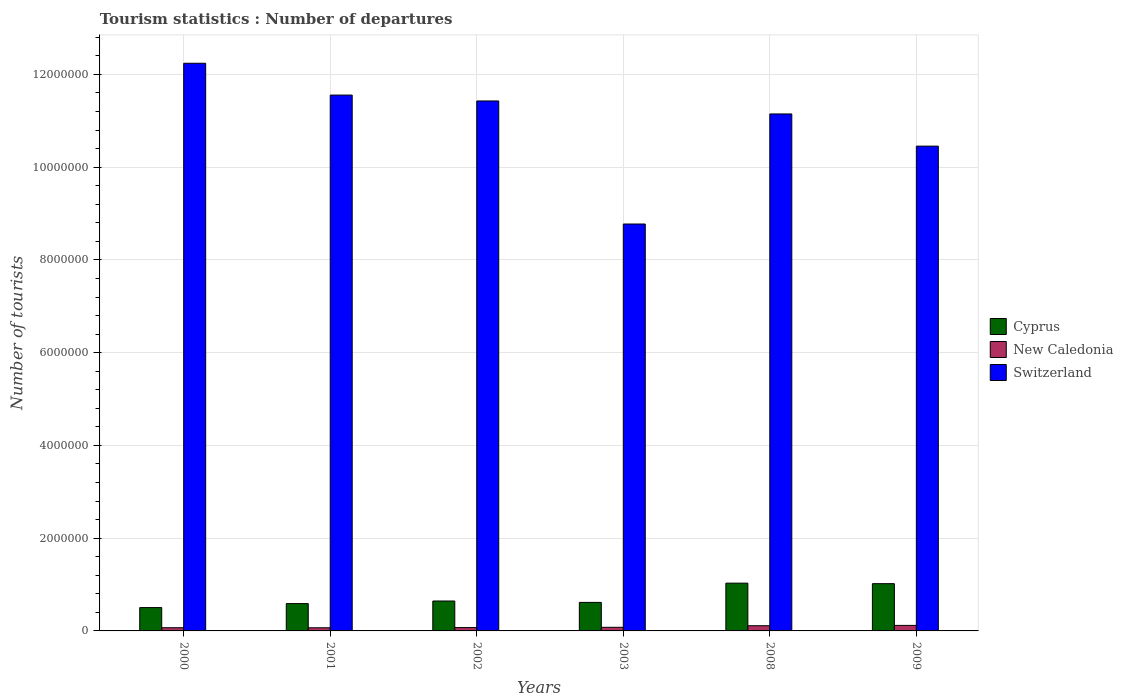How many different coloured bars are there?
Your response must be concise. 3. Are the number of bars per tick equal to the number of legend labels?
Your answer should be compact. Yes. How many bars are there on the 6th tick from the right?
Give a very brief answer. 3. In how many cases, is the number of bars for a given year not equal to the number of legend labels?
Ensure brevity in your answer.  0. What is the number of tourist departures in Cyprus in 2003?
Give a very brief answer. 6.15e+05. Across all years, what is the maximum number of tourist departures in Switzerland?
Your answer should be very brief. 1.22e+07. Across all years, what is the minimum number of tourist departures in New Caledonia?
Offer a terse response. 6.80e+04. In which year was the number of tourist departures in New Caledonia minimum?
Your answer should be very brief. 2001. What is the total number of tourist departures in Switzerland in the graph?
Ensure brevity in your answer.  6.56e+07. What is the difference between the number of tourist departures in Cyprus in 2002 and that in 2009?
Your response must be concise. -3.74e+05. What is the difference between the number of tourist departures in New Caledonia in 2001 and the number of tourist departures in Switzerland in 2002?
Give a very brief answer. -1.14e+07. What is the average number of tourist departures in New Caledonia per year?
Keep it short and to the point. 8.63e+04. In the year 2001, what is the difference between the number of tourist departures in New Caledonia and number of tourist departures in Cyprus?
Offer a very short reply. -5.21e+05. In how many years, is the number of tourist departures in Cyprus greater than 2400000?
Offer a very short reply. 0. What is the ratio of the number of tourist departures in Cyprus in 2001 to that in 2008?
Keep it short and to the point. 0.57. Is the number of tourist departures in Cyprus in 2000 less than that in 2009?
Provide a succinct answer. Yes. Is the difference between the number of tourist departures in New Caledonia in 2000 and 2009 greater than the difference between the number of tourist departures in Cyprus in 2000 and 2009?
Provide a short and direct response. Yes. What is the difference between the highest and the second highest number of tourist departures in New Caledonia?
Provide a succinct answer. 7000. What is the difference between the highest and the lowest number of tourist departures in Cyprus?
Your response must be concise. 5.27e+05. Is the sum of the number of tourist departures in Cyprus in 2000 and 2008 greater than the maximum number of tourist departures in New Caledonia across all years?
Offer a terse response. Yes. What does the 1st bar from the left in 2002 represents?
Your answer should be compact. Cyprus. What does the 2nd bar from the right in 2009 represents?
Offer a terse response. New Caledonia. Is it the case that in every year, the sum of the number of tourist departures in Switzerland and number of tourist departures in New Caledonia is greater than the number of tourist departures in Cyprus?
Your answer should be compact. Yes. How many bars are there?
Your response must be concise. 18. Are all the bars in the graph horizontal?
Your answer should be very brief. No. Are the values on the major ticks of Y-axis written in scientific E-notation?
Offer a terse response. No. Does the graph contain any zero values?
Offer a terse response. No. Does the graph contain grids?
Your answer should be compact. Yes. Where does the legend appear in the graph?
Your answer should be compact. Center right. What is the title of the graph?
Your answer should be compact. Tourism statistics : Number of departures. Does "Tunisia" appear as one of the legend labels in the graph?
Provide a short and direct response. No. What is the label or title of the Y-axis?
Your answer should be compact. Number of tourists. What is the Number of tourists of Cyprus in 2000?
Give a very brief answer. 5.03e+05. What is the Number of tourists in New Caledonia in 2000?
Give a very brief answer. 6.90e+04. What is the Number of tourists of Switzerland in 2000?
Your answer should be compact. 1.22e+07. What is the Number of tourists of Cyprus in 2001?
Your answer should be very brief. 5.89e+05. What is the Number of tourists of New Caledonia in 2001?
Offer a terse response. 6.80e+04. What is the Number of tourists in Switzerland in 2001?
Your answer should be very brief. 1.16e+07. What is the Number of tourists of Cyprus in 2002?
Make the answer very short. 6.45e+05. What is the Number of tourists of New Caledonia in 2002?
Keep it short and to the point. 7.20e+04. What is the Number of tourists of Switzerland in 2002?
Offer a very short reply. 1.14e+07. What is the Number of tourists in Cyprus in 2003?
Your answer should be very brief. 6.15e+05. What is the Number of tourists in New Caledonia in 2003?
Your answer should be compact. 7.80e+04. What is the Number of tourists in Switzerland in 2003?
Keep it short and to the point. 8.77e+06. What is the Number of tourists in Cyprus in 2008?
Your answer should be very brief. 1.03e+06. What is the Number of tourists of New Caledonia in 2008?
Offer a terse response. 1.12e+05. What is the Number of tourists in Switzerland in 2008?
Offer a terse response. 1.11e+07. What is the Number of tourists in Cyprus in 2009?
Your answer should be very brief. 1.02e+06. What is the Number of tourists in New Caledonia in 2009?
Offer a very short reply. 1.19e+05. What is the Number of tourists in Switzerland in 2009?
Provide a succinct answer. 1.05e+07. Across all years, what is the maximum Number of tourists in Cyprus?
Your answer should be very brief. 1.03e+06. Across all years, what is the maximum Number of tourists in New Caledonia?
Offer a terse response. 1.19e+05. Across all years, what is the maximum Number of tourists in Switzerland?
Ensure brevity in your answer.  1.22e+07. Across all years, what is the minimum Number of tourists in Cyprus?
Offer a terse response. 5.03e+05. Across all years, what is the minimum Number of tourists in New Caledonia?
Your answer should be very brief. 6.80e+04. Across all years, what is the minimum Number of tourists of Switzerland?
Keep it short and to the point. 8.77e+06. What is the total Number of tourists in Cyprus in the graph?
Keep it short and to the point. 4.40e+06. What is the total Number of tourists in New Caledonia in the graph?
Provide a succinct answer. 5.18e+05. What is the total Number of tourists in Switzerland in the graph?
Make the answer very short. 6.56e+07. What is the difference between the Number of tourists of Cyprus in 2000 and that in 2001?
Provide a short and direct response. -8.60e+04. What is the difference between the Number of tourists of Switzerland in 2000 and that in 2001?
Your response must be concise. 6.86e+05. What is the difference between the Number of tourists in Cyprus in 2000 and that in 2002?
Make the answer very short. -1.42e+05. What is the difference between the Number of tourists in New Caledonia in 2000 and that in 2002?
Provide a short and direct response. -3000. What is the difference between the Number of tourists of Switzerland in 2000 and that in 2002?
Your response must be concise. 8.13e+05. What is the difference between the Number of tourists in Cyprus in 2000 and that in 2003?
Give a very brief answer. -1.12e+05. What is the difference between the Number of tourists in New Caledonia in 2000 and that in 2003?
Keep it short and to the point. -9000. What is the difference between the Number of tourists in Switzerland in 2000 and that in 2003?
Give a very brief answer. 3.47e+06. What is the difference between the Number of tourists of Cyprus in 2000 and that in 2008?
Your answer should be compact. -5.27e+05. What is the difference between the Number of tourists in New Caledonia in 2000 and that in 2008?
Your response must be concise. -4.30e+04. What is the difference between the Number of tourists in Switzerland in 2000 and that in 2008?
Provide a succinct answer. 1.09e+06. What is the difference between the Number of tourists in Cyprus in 2000 and that in 2009?
Your answer should be compact. -5.16e+05. What is the difference between the Number of tourists of Switzerland in 2000 and that in 2009?
Provide a succinct answer. 1.79e+06. What is the difference between the Number of tourists in Cyprus in 2001 and that in 2002?
Your response must be concise. -5.60e+04. What is the difference between the Number of tourists of New Caledonia in 2001 and that in 2002?
Offer a very short reply. -4000. What is the difference between the Number of tourists in Switzerland in 2001 and that in 2002?
Offer a terse response. 1.27e+05. What is the difference between the Number of tourists of Cyprus in 2001 and that in 2003?
Offer a terse response. -2.60e+04. What is the difference between the Number of tourists in Switzerland in 2001 and that in 2003?
Offer a terse response. 2.78e+06. What is the difference between the Number of tourists in Cyprus in 2001 and that in 2008?
Ensure brevity in your answer.  -4.41e+05. What is the difference between the Number of tourists in New Caledonia in 2001 and that in 2008?
Your answer should be compact. -4.40e+04. What is the difference between the Number of tourists in Switzerland in 2001 and that in 2008?
Make the answer very short. 4.07e+05. What is the difference between the Number of tourists in Cyprus in 2001 and that in 2009?
Provide a short and direct response. -4.30e+05. What is the difference between the Number of tourists of New Caledonia in 2001 and that in 2009?
Make the answer very short. -5.10e+04. What is the difference between the Number of tourists in Switzerland in 2001 and that in 2009?
Make the answer very short. 1.10e+06. What is the difference between the Number of tourists in Cyprus in 2002 and that in 2003?
Make the answer very short. 3.00e+04. What is the difference between the Number of tourists of New Caledonia in 2002 and that in 2003?
Ensure brevity in your answer.  -6000. What is the difference between the Number of tourists of Switzerland in 2002 and that in 2003?
Offer a very short reply. 2.65e+06. What is the difference between the Number of tourists in Cyprus in 2002 and that in 2008?
Give a very brief answer. -3.85e+05. What is the difference between the Number of tourists in Cyprus in 2002 and that in 2009?
Your answer should be very brief. -3.74e+05. What is the difference between the Number of tourists in New Caledonia in 2002 and that in 2009?
Offer a very short reply. -4.70e+04. What is the difference between the Number of tourists in Switzerland in 2002 and that in 2009?
Provide a succinct answer. 9.74e+05. What is the difference between the Number of tourists of Cyprus in 2003 and that in 2008?
Ensure brevity in your answer.  -4.15e+05. What is the difference between the Number of tourists in New Caledonia in 2003 and that in 2008?
Make the answer very short. -3.40e+04. What is the difference between the Number of tourists in Switzerland in 2003 and that in 2008?
Ensure brevity in your answer.  -2.37e+06. What is the difference between the Number of tourists in Cyprus in 2003 and that in 2009?
Offer a very short reply. -4.04e+05. What is the difference between the Number of tourists in New Caledonia in 2003 and that in 2009?
Make the answer very short. -4.10e+04. What is the difference between the Number of tourists of Switzerland in 2003 and that in 2009?
Ensure brevity in your answer.  -1.68e+06. What is the difference between the Number of tourists in Cyprus in 2008 and that in 2009?
Your answer should be very brief. 1.10e+04. What is the difference between the Number of tourists of New Caledonia in 2008 and that in 2009?
Ensure brevity in your answer.  -7000. What is the difference between the Number of tourists of Switzerland in 2008 and that in 2009?
Offer a terse response. 6.94e+05. What is the difference between the Number of tourists in Cyprus in 2000 and the Number of tourists in New Caledonia in 2001?
Your answer should be very brief. 4.35e+05. What is the difference between the Number of tourists of Cyprus in 2000 and the Number of tourists of Switzerland in 2001?
Provide a succinct answer. -1.11e+07. What is the difference between the Number of tourists of New Caledonia in 2000 and the Number of tourists of Switzerland in 2001?
Offer a terse response. -1.15e+07. What is the difference between the Number of tourists of Cyprus in 2000 and the Number of tourists of New Caledonia in 2002?
Give a very brief answer. 4.31e+05. What is the difference between the Number of tourists in Cyprus in 2000 and the Number of tourists in Switzerland in 2002?
Offer a terse response. -1.09e+07. What is the difference between the Number of tourists of New Caledonia in 2000 and the Number of tourists of Switzerland in 2002?
Provide a succinct answer. -1.14e+07. What is the difference between the Number of tourists in Cyprus in 2000 and the Number of tourists in New Caledonia in 2003?
Offer a very short reply. 4.25e+05. What is the difference between the Number of tourists of Cyprus in 2000 and the Number of tourists of Switzerland in 2003?
Provide a succinct answer. -8.27e+06. What is the difference between the Number of tourists in New Caledonia in 2000 and the Number of tourists in Switzerland in 2003?
Keep it short and to the point. -8.70e+06. What is the difference between the Number of tourists of Cyprus in 2000 and the Number of tourists of New Caledonia in 2008?
Give a very brief answer. 3.91e+05. What is the difference between the Number of tourists of Cyprus in 2000 and the Number of tourists of Switzerland in 2008?
Your answer should be very brief. -1.06e+07. What is the difference between the Number of tourists in New Caledonia in 2000 and the Number of tourists in Switzerland in 2008?
Your response must be concise. -1.11e+07. What is the difference between the Number of tourists in Cyprus in 2000 and the Number of tourists in New Caledonia in 2009?
Ensure brevity in your answer.  3.84e+05. What is the difference between the Number of tourists of Cyprus in 2000 and the Number of tourists of Switzerland in 2009?
Give a very brief answer. -9.95e+06. What is the difference between the Number of tourists of New Caledonia in 2000 and the Number of tourists of Switzerland in 2009?
Keep it short and to the point. -1.04e+07. What is the difference between the Number of tourists in Cyprus in 2001 and the Number of tourists in New Caledonia in 2002?
Your answer should be compact. 5.17e+05. What is the difference between the Number of tourists in Cyprus in 2001 and the Number of tourists in Switzerland in 2002?
Your answer should be compact. -1.08e+07. What is the difference between the Number of tourists in New Caledonia in 2001 and the Number of tourists in Switzerland in 2002?
Provide a short and direct response. -1.14e+07. What is the difference between the Number of tourists of Cyprus in 2001 and the Number of tourists of New Caledonia in 2003?
Make the answer very short. 5.11e+05. What is the difference between the Number of tourists in Cyprus in 2001 and the Number of tourists in Switzerland in 2003?
Offer a terse response. -8.18e+06. What is the difference between the Number of tourists of New Caledonia in 2001 and the Number of tourists of Switzerland in 2003?
Make the answer very short. -8.71e+06. What is the difference between the Number of tourists of Cyprus in 2001 and the Number of tourists of New Caledonia in 2008?
Offer a very short reply. 4.77e+05. What is the difference between the Number of tourists of Cyprus in 2001 and the Number of tourists of Switzerland in 2008?
Offer a terse response. -1.06e+07. What is the difference between the Number of tourists in New Caledonia in 2001 and the Number of tourists in Switzerland in 2008?
Give a very brief answer. -1.11e+07. What is the difference between the Number of tourists in Cyprus in 2001 and the Number of tourists in Switzerland in 2009?
Your answer should be compact. -9.86e+06. What is the difference between the Number of tourists of New Caledonia in 2001 and the Number of tourists of Switzerland in 2009?
Your response must be concise. -1.04e+07. What is the difference between the Number of tourists in Cyprus in 2002 and the Number of tourists in New Caledonia in 2003?
Provide a succinct answer. 5.67e+05. What is the difference between the Number of tourists of Cyprus in 2002 and the Number of tourists of Switzerland in 2003?
Give a very brief answer. -8.13e+06. What is the difference between the Number of tourists of New Caledonia in 2002 and the Number of tourists of Switzerland in 2003?
Your response must be concise. -8.70e+06. What is the difference between the Number of tourists of Cyprus in 2002 and the Number of tourists of New Caledonia in 2008?
Your answer should be very brief. 5.33e+05. What is the difference between the Number of tourists of Cyprus in 2002 and the Number of tourists of Switzerland in 2008?
Offer a very short reply. -1.05e+07. What is the difference between the Number of tourists in New Caledonia in 2002 and the Number of tourists in Switzerland in 2008?
Your answer should be compact. -1.11e+07. What is the difference between the Number of tourists of Cyprus in 2002 and the Number of tourists of New Caledonia in 2009?
Your response must be concise. 5.26e+05. What is the difference between the Number of tourists in Cyprus in 2002 and the Number of tourists in Switzerland in 2009?
Provide a succinct answer. -9.81e+06. What is the difference between the Number of tourists in New Caledonia in 2002 and the Number of tourists in Switzerland in 2009?
Give a very brief answer. -1.04e+07. What is the difference between the Number of tourists of Cyprus in 2003 and the Number of tourists of New Caledonia in 2008?
Provide a short and direct response. 5.03e+05. What is the difference between the Number of tourists of Cyprus in 2003 and the Number of tourists of Switzerland in 2008?
Keep it short and to the point. -1.05e+07. What is the difference between the Number of tourists of New Caledonia in 2003 and the Number of tourists of Switzerland in 2008?
Ensure brevity in your answer.  -1.11e+07. What is the difference between the Number of tourists of Cyprus in 2003 and the Number of tourists of New Caledonia in 2009?
Offer a terse response. 4.96e+05. What is the difference between the Number of tourists in Cyprus in 2003 and the Number of tourists in Switzerland in 2009?
Provide a short and direct response. -9.84e+06. What is the difference between the Number of tourists in New Caledonia in 2003 and the Number of tourists in Switzerland in 2009?
Your answer should be very brief. -1.04e+07. What is the difference between the Number of tourists of Cyprus in 2008 and the Number of tourists of New Caledonia in 2009?
Offer a very short reply. 9.11e+05. What is the difference between the Number of tourists in Cyprus in 2008 and the Number of tourists in Switzerland in 2009?
Keep it short and to the point. -9.42e+06. What is the difference between the Number of tourists of New Caledonia in 2008 and the Number of tourists of Switzerland in 2009?
Make the answer very short. -1.03e+07. What is the average Number of tourists in Cyprus per year?
Provide a short and direct response. 7.34e+05. What is the average Number of tourists in New Caledonia per year?
Make the answer very short. 8.63e+04. What is the average Number of tourists of Switzerland per year?
Provide a succinct answer. 1.09e+07. In the year 2000, what is the difference between the Number of tourists in Cyprus and Number of tourists in New Caledonia?
Provide a short and direct response. 4.34e+05. In the year 2000, what is the difference between the Number of tourists of Cyprus and Number of tourists of Switzerland?
Provide a short and direct response. -1.17e+07. In the year 2000, what is the difference between the Number of tourists of New Caledonia and Number of tourists of Switzerland?
Your answer should be compact. -1.22e+07. In the year 2001, what is the difference between the Number of tourists in Cyprus and Number of tourists in New Caledonia?
Offer a very short reply. 5.21e+05. In the year 2001, what is the difference between the Number of tourists of Cyprus and Number of tourists of Switzerland?
Provide a succinct answer. -1.10e+07. In the year 2001, what is the difference between the Number of tourists of New Caledonia and Number of tourists of Switzerland?
Your answer should be compact. -1.15e+07. In the year 2002, what is the difference between the Number of tourists of Cyprus and Number of tourists of New Caledonia?
Your response must be concise. 5.73e+05. In the year 2002, what is the difference between the Number of tourists of Cyprus and Number of tourists of Switzerland?
Your answer should be very brief. -1.08e+07. In the year 2002, what is the difference between the Number of tourists of New Caledonia and Number of tourists of Switzerland?
Provide a succinct answer. -1.14e+07. In the year 2003, what is the difference between the Number of tourists of Cyprus and Number of tourists of New Caledonia?
Offer a terse response. 5.37e+05. In the year 2003, what is the difference between the Number of tourists of Cyprus and Number of tourists of Switzerland?
Provide a short and direct response. -8.16e+06. In the year 2003, what is the difference between the Number of tourists in New Caledonia and Number of tourists in Switzerland?
Offer a terse response. -8.70e+06. In the year 2008, what is the difference between the Number of tourists in Cyprus and Number of tourists in New Caledonia?
Your response must be concise. 9.18e+05. In the year 2008, what is the difference between the Number of tourists in Cyprus and Number of tourists in Switzerland?
Provide a short and direct response. -1.01e+07. In the year 2008, what is the difference between the Number of tourists in New Caledonia and Number of tourists in Switzerland?
Your answer should be very brief. -1.10e+07. In the year 2009, what is the difference between the Number of tourists of Cyprus and Number of tourists of Switzerland?
Your answer should be very brief. -9.43e+06. In the year 2009, what is the difference between the Number of tourists of New Caledonia and Number of tourists of Switzerland?
Your response must be concise. -1.03e+07. What is the ratio of the Number of tourists in Cyprus in 2000 to that in 2001?
Provide a succinct answer. 0.85. What is the ratio of the Number of tourists in New Caledonia in 2000 to that in 2001?
Provide a short and direct response. 1.01. What is the ratio of the Number of tourists of Switzerland in 2000 to that in 2001?
Provide a short and direct response. 1.06. What is the ratio of the Number of tourists of Cyprus in 2000 to that in 2002?
Provide a succinct answer. 0.78. What is the ratio of the Number of tourists in Switzerland in 2000 to that in 2002?
Offer a very short reply. 1.07. What is the ratio of the Number of tourists in Cyprus in 2000 to that in 2003?
Make the answer very short. 0.82. What is the ratio of the Number of tourists of New Caledonia in 2000 to that in 2003?
Make the answer very short. 0.88. What is the ratio of the Number of tourists of Switzerland in 2000 to that in 2003?
Provide a succinct answer. 1.4. What is the ratio of the Number of tourists in Cyprus in 2000 to that in 2008?
Keep it short and to the point. 0.49. What is the ratio of the Number of tourists in New Caledonia in 2000 to that in 2008?
Offer a terse response. 0.62. What is the ratio of the Number of tourists of Switzerland in 2000 to that in 2008?
Make the answer very short. 1.1. What is the ratio of the Number of tourists in Cyprus in 2000 to that in 2009?
Make the answer very short. 0.49. What is the ratio of the Number of tourists of New Caledonia in 2000 to that in 2009?
Ensure brevity in your answer.  0.58. What is the ratio of the Number of tourists in Switzerland in 2000 to that in 2009?
Provide a short and direct response. 1.17. What is the ratio of the Number of tourists of Cyprus in 2001 to that in 2002?
Ensure brevity in your answer.  0.91. What is the ratio of the Number of tourists of New Caledonia in 2001 to that in 2002?
Provide a succinct answer. 0.94. What is the ratio of the Number of tourists in Switzerland in 2001 to that in 2002?
Make the answer very short. 1.01. What is the ratio of the Number of tourists in Cyprus in 2001 to that in 2003?
Offer a very short reply. 0.96. What is the ratio of the Number of tourists in New Caledonia in 2001 to that in 2003?
Your answer should be very brief. 0.87. What is the ratio of the Number of tourists in Switzerland in 2001 to that in 2003?
Offer a terse response. 1.32. What is the ratio of the Number of tourists in Cyprus in 2001 to that in 2008?
Provide a succinct answer. 0.57. What is the ratio of the Number of tourists of New Caledonia in 2001 to that in 2008?
Your answer should be compact. 0.61. What is the ratio of the Number of tourists of Switzerland in 2001 to that in 2008?
Offer a terse response. 1.04. What is the ratio of the Number of tourists in Cyprus in 2001 to that in 2009?
Provide a succinct answer. 0.58. What is the ratio of the Number of tourists of Switzerland in 2001 to that in 2009?
Provide a short and direct response. 1.11. What is the ratio of the Number of tourists of Cyprus in 2002 to that in 2003?
Make the answer very short. 1.05. What is the ratio of the Number of tourists in Switzerland in 2002 to that in 2003?
Give a very brief answer. 1.3. What is the ratio of the Number of tourists in Cyprus in 2002 to that in 2008?
Offer a very short reply. 0.63. What is the ratio of the Number of tourists of New Caledonia in 2002 to that in 2008?
Offer a very short reply. 0.64. What is the ratio of the Number of tourists of Switzerland in 2002 to that in 2008?
Your response must be concise. 1.03. What is the ratio of the Number of tourists in Cyprus in 2002 to that in 2009?
Ensure brevity in your answer.  0.63. What is the ratio of the Number of tourists in New Caledonia in 2002 to that in 2009?
Offer a very short reply. 0.6. What is the ratio of the Number of tourists of Switzerland in 2002 to that in 2009?
Keep it short and to the point. 1.09. What is the ratio of the Number of tourists of Cyprus in 2003 to that in 2008?
Provide a short and direct response. 0.6. What is the ratio of the Number of tourists of New Caledonia in 2003 to that in 2008?
Your response must be concise. 0.7. What is the ratio of the Number of tourists of Switzerland in 2003 to that in 2008?
Keep it short and to the point. 0.79. What is the ratio of the Number of tourists of Cyprus in 2003 to that in 2009?
Keep it short and to the point. 0.6. What is the ratio of the Number of tourists of New Caledonia in 2003 to that in 2009?
Give a very brief answer. 0.66. What is the ratio of the Number of tourists of Switzerland in 2003 to that in 2009?
Your answer should be very brief. 0.84. What is the ratio of the Number of tourists in Cyprus in 2008 to that in 2009?
Keep it short and to the point. 1.01. What is the ratio of the Number of tourists in Switzerland in 2008 to that in 2009?
Ensure brevity in your answer.  1.07. What is the difference between the highest and the second highest Number of tourists in Cyprus?
Your response must be concise. 1.10e+04. What is the difference between the highest and the second highest Number of tourists in New Caledonia?
Keep it short and to the point. 7000. What is the difference between the highest and the second highest Number of tourists in Switzerland?
Offer a very short reply. 6.86e+05. What is the difference between the highest and the lowest Number of tourists of Cyprus?
Provide a short and direct response. 5.27e+05. What is the difference between the highest and the lowest Number of tourists in New Caledonia?
Offer a very short reply. 5.10e+04. What is the difference between the highest and the lowest Number of tourists in Switzerland?
Keep it short and to the point. 3.47e+06. 